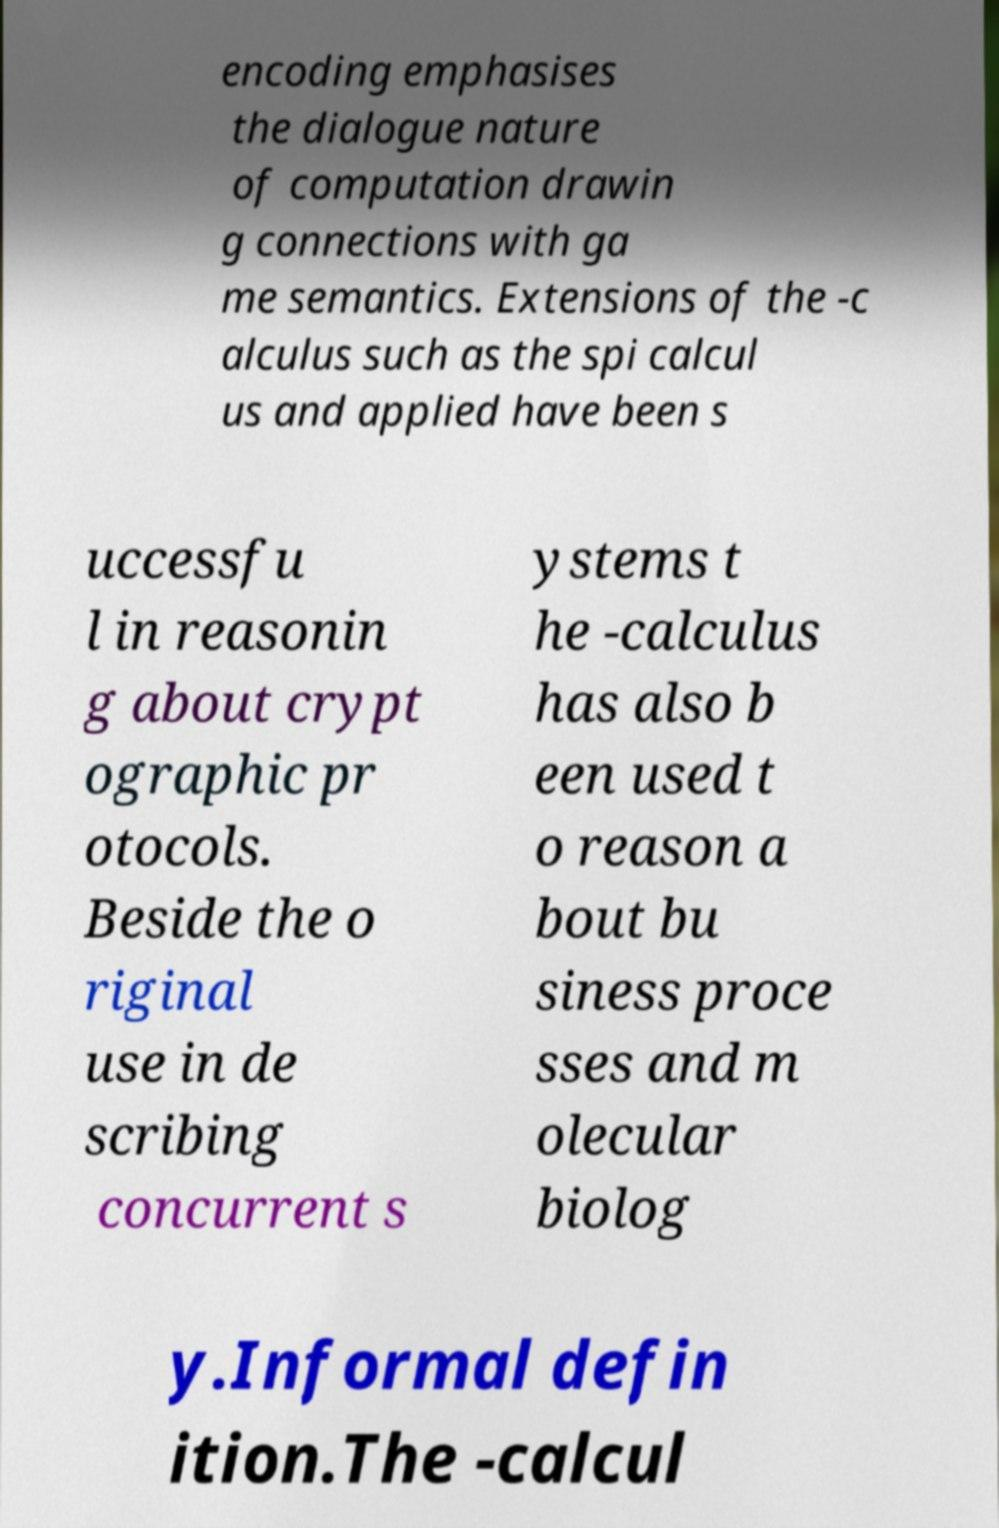For documentation purposes, I need the text within this image transcribed. Could you provide that? encoding emphasises the dialogue nature of computation drawin g connections with ga me semantics. Extensions of the -c alculus such as the spi calcul us and applied have been s uccessfu l in reasonin g about crypt ographic pr otocols. Beside the o riginal use in de scribing concurrent s ystems t he -calculus has also b een used t o reason a bout bu siness proce sses and m olecular biolog y.Informal defin ition.The -calcul 